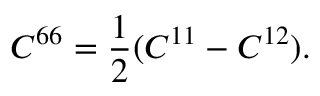Convert formula to latex. <formula><loc_0><loc_0><loc_500><loc_500>C ^ { 6 6 } = \frac { 1 } { 2 } ( C ^ { 1 1 } - C ^ { 1 2 } ) .</formula> 